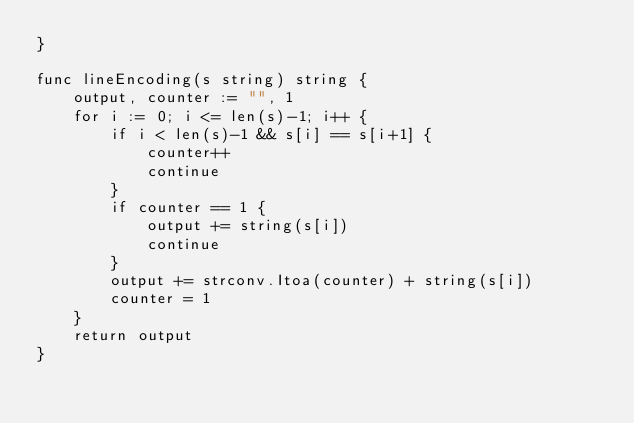Convert code to text. <code><loc_0><loc_0><loc_500><loc_500><_Go_>}

func lineEncoding(s string) string {
	output, counter := "", 1
	for i := 0; i <= len(s)-1; i++ {
		if i < len(s)-1 && s[i] == s[i+1] {
			counter++
			continue
		}
		if counter == 1 {
			output += string(s[i])
			continue
		}
		output += strconv.Itoa(counter) + string(s[i])
		counter = 1
	}
	return output
}
</code> 